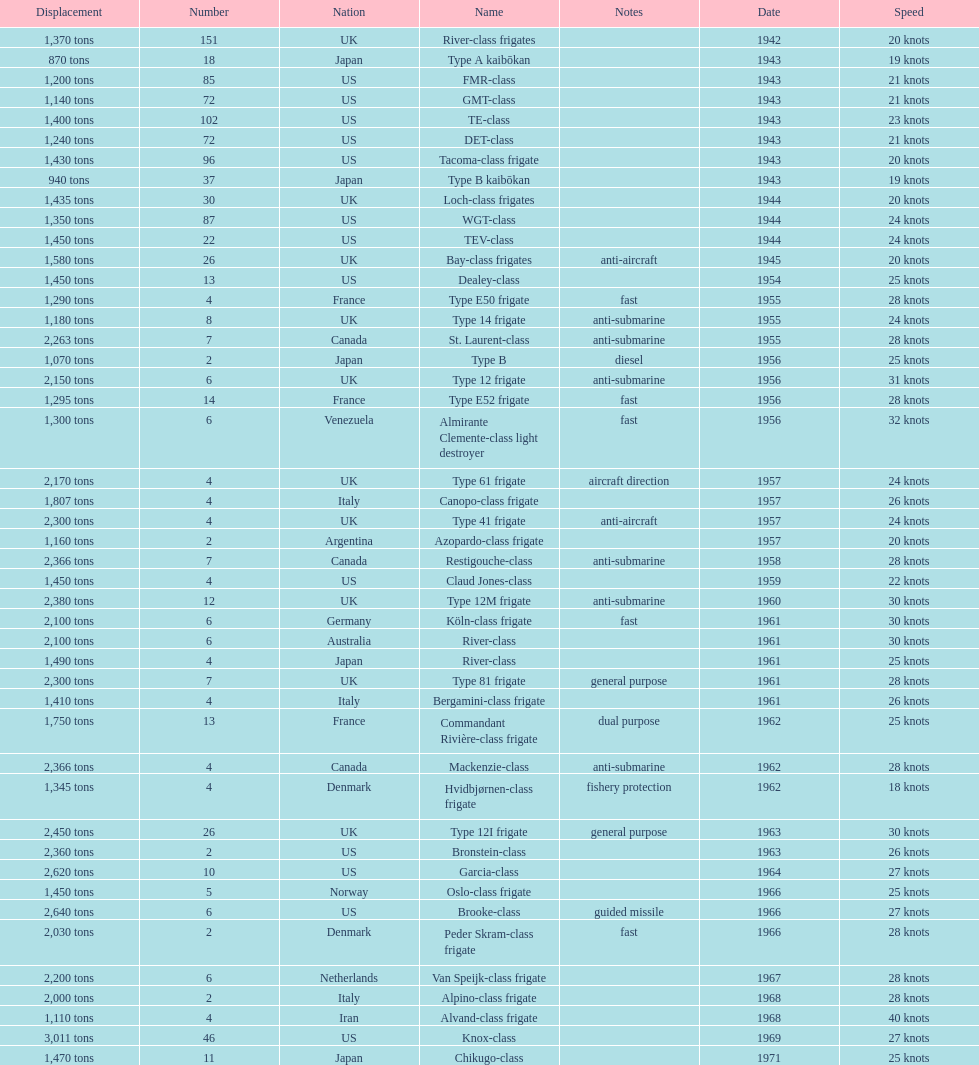How many consecutive escorts were in 1943? 7. 